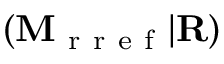<formula> <loc_0><loc_0><loc_500><loc_500>( M _ { r r e f } | R )</formula> 